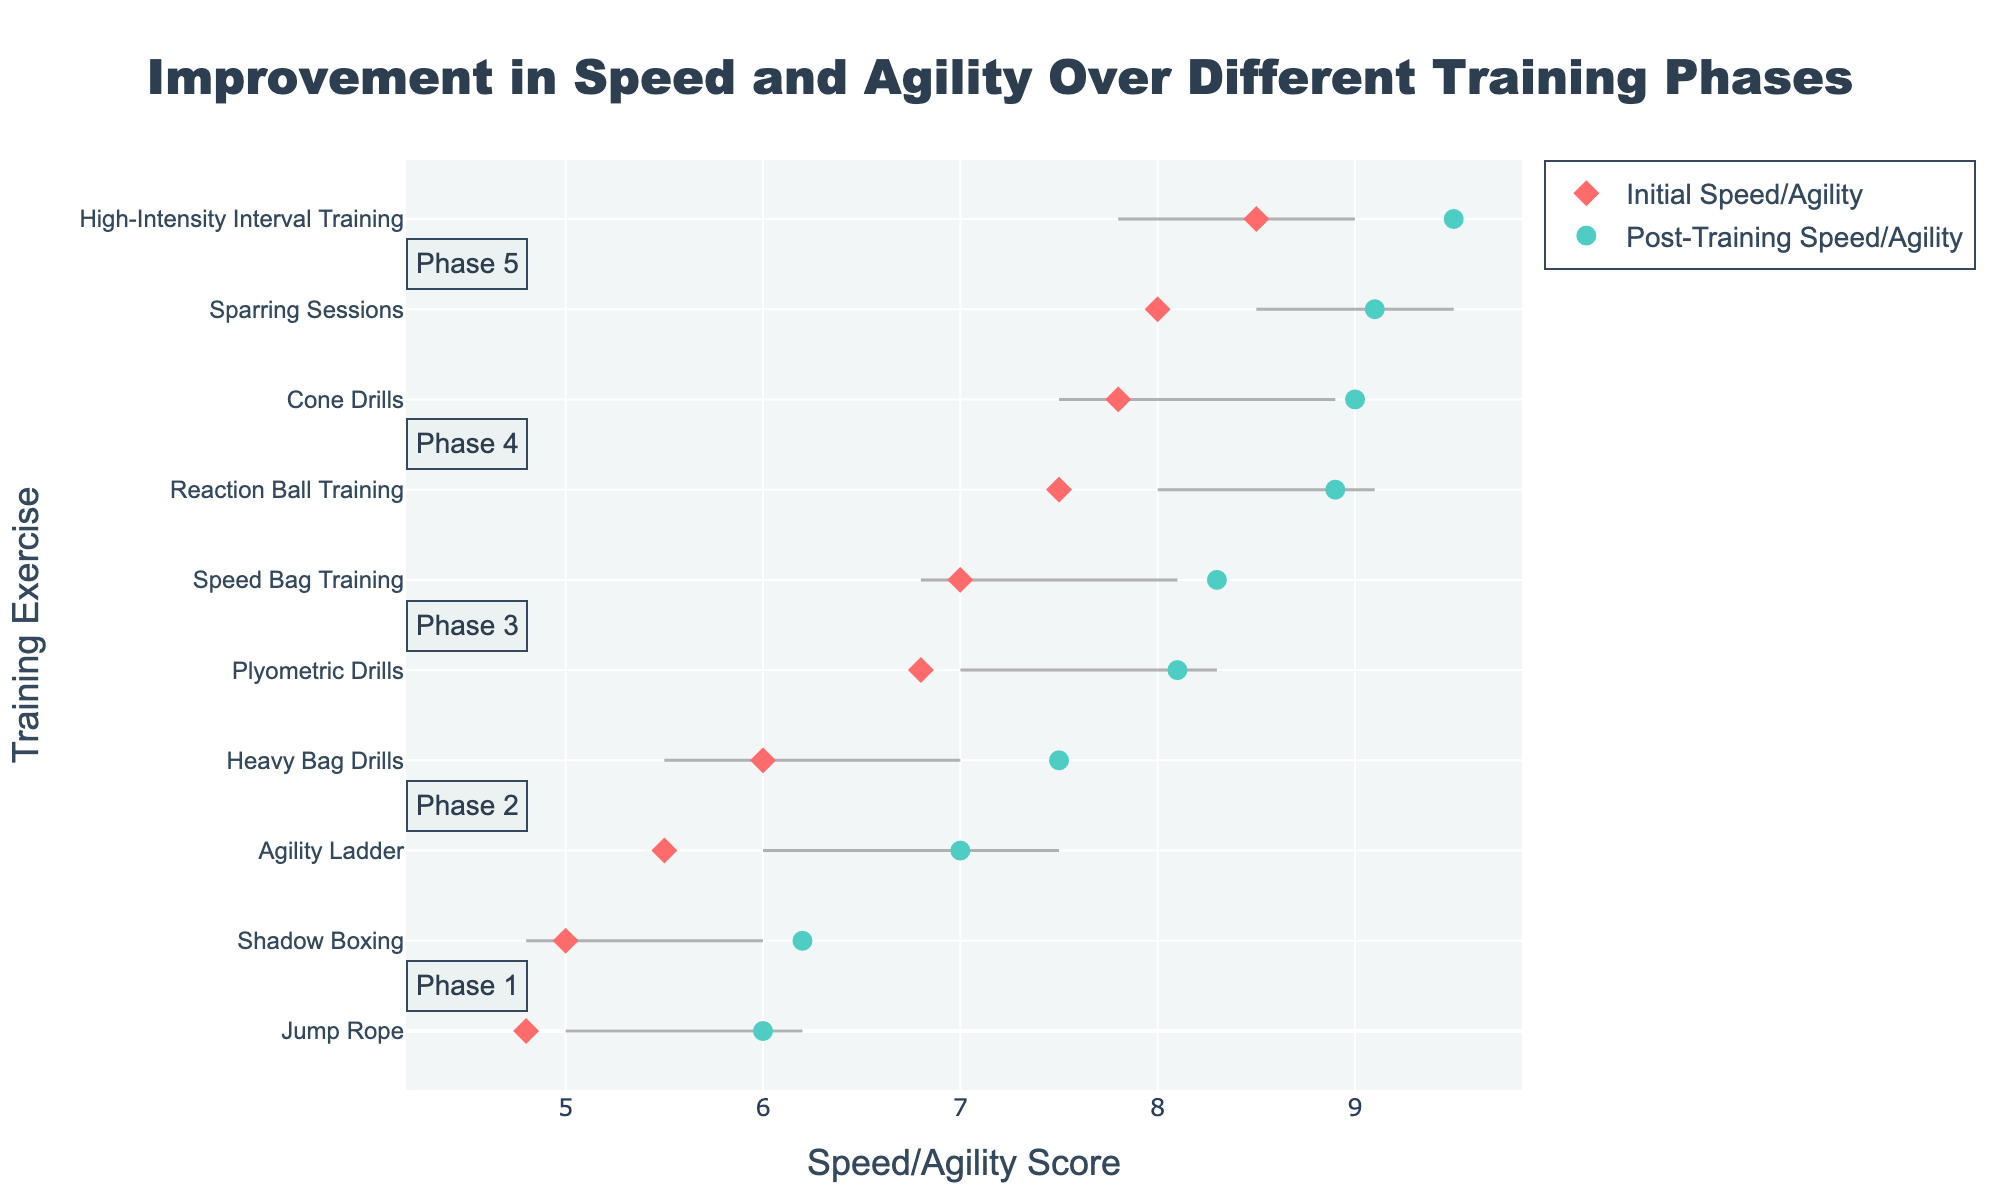What is the title of the plot? The title is written at the top of the plot and describes the focus of the figure.
Answer: Improvement in Speed and Agility Over Different Training Phases Which exercise had the highest initial speed/agility score? By looking at the initial speed/agility markers (diamonds), you can find the highest score.
Answer: High-Intensity Interval Training What is the color of the markers representing post-training speed/agility? The markers for post-training speed/agility are distinctively colored.
Answer: Cyan How much improvement did the "Heavy Bag Drills" exercise show from initial to post-training? Locate the "Heavy Bag Drills" line and check the difference between the initial and post-training values.
Answer: 1.5 Which phase contains the exercise with the lowest initial speed/agility score? Identify the exercise with the lowest initial marker, then look at the respective phase.
Answer: Phase 1 What is the average initial speed/agility score across all exercises? Add all initial scores and divide by the total number of exercises: (5.0 + 4.8 + 6.0 + 5.5 + 7.0 + 6.8 + 8.0 + 7.5 + 8.5 + 7.8) / 10 = 6.89.
Answer: 6.89 Which exercise had the greatest improvement in speed/agility? Compare the lengths of lines representing the difference between initial and post-training values for each exercise.
Answer: Cone Drills Is there any exercise that did not improve after training? Look at all the lines; if any line is horizontal, that means no improvement was shown.
Answer: No In which phase is the average post-training speed/agility score the highest? Calculate the average post-training scores for each phase and compare. Phase 5: (9.5 + 9.0) / 2 = 9.25, highest among all.
Answer: Phase 5 